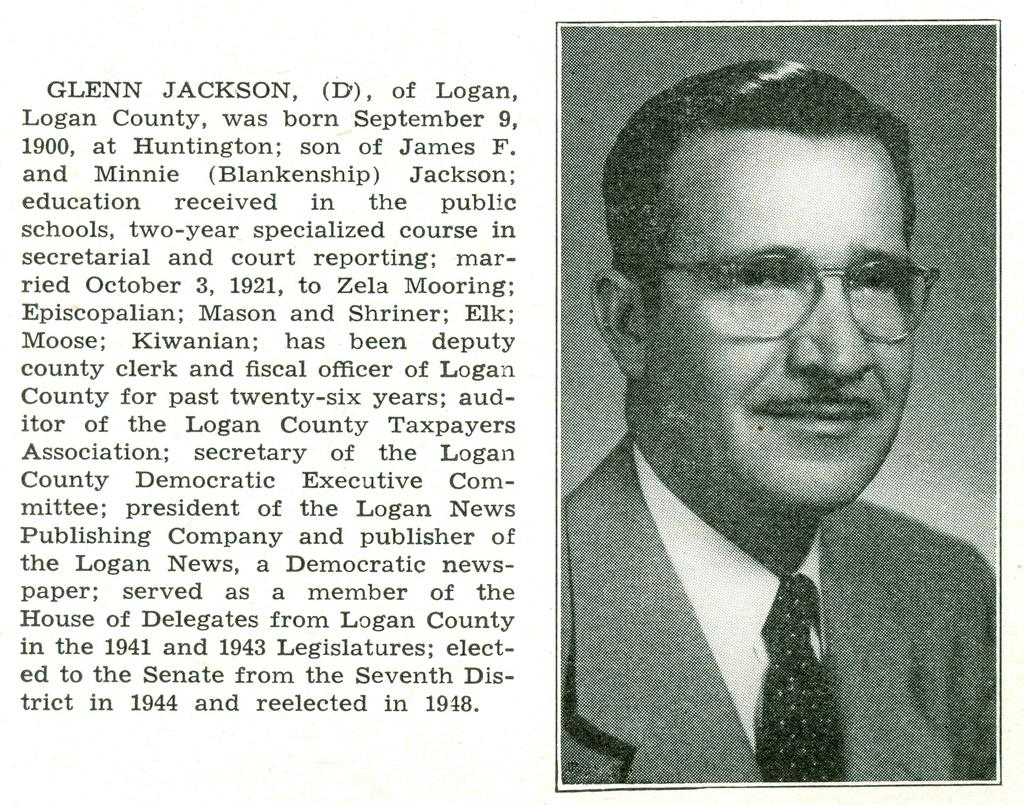What type of content is featured in the image? There is a newspaper article in the image. Can you describe the person in the image? The person in the image is wearing a white shirt, a tie, a blazerazer, and spectacles. What is the person's attire in the image? The person is wearing a white shirt, a tie, and a blazer. What accessory is the person wearing in the image? The person is wearing spectacles in the image. What type of animals can be seen at the zoo in the image? There is no zoo or animals present in the image; it features a newspaper article with a picture of a person wearing a white shirt, a tie, a blazer, and spectacles. 